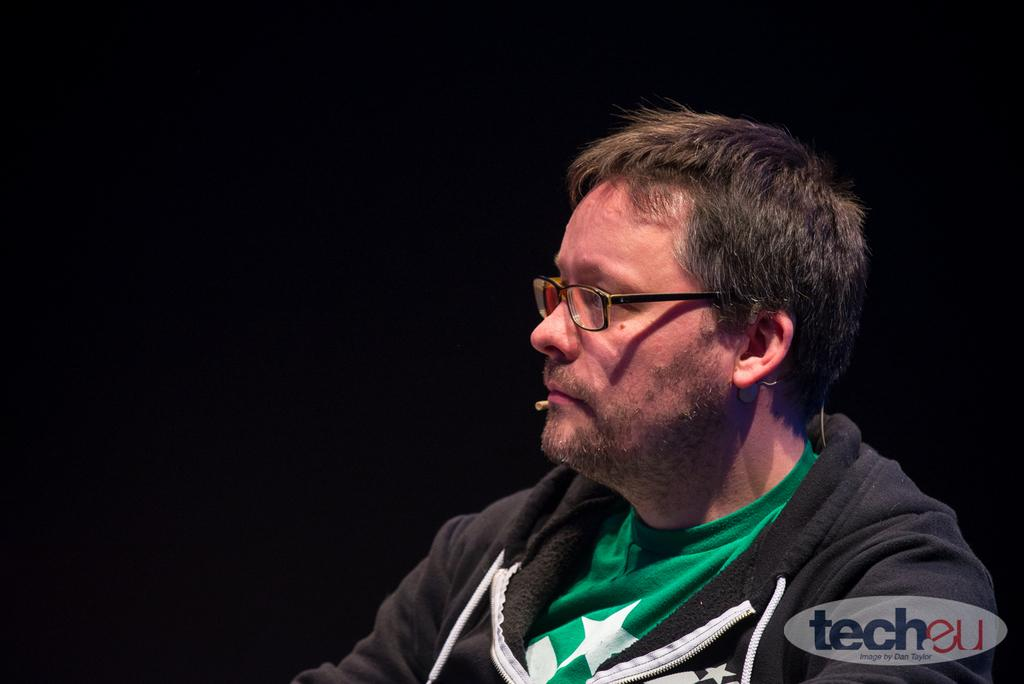What can be found in the bottom right corner of the image? There is a watermark in the bottom right corner of the image. Where is the person located in the image? The person is on the right side of the image. What is the person wearing in the image? The person is wearing spectacles. What is the person doing in the image? The person is watching something. How would you describe the background of the image? The background of the image is dark in color. How many cats are performing a twist dance in the image? There are no cats or any dance performance present in the image. 